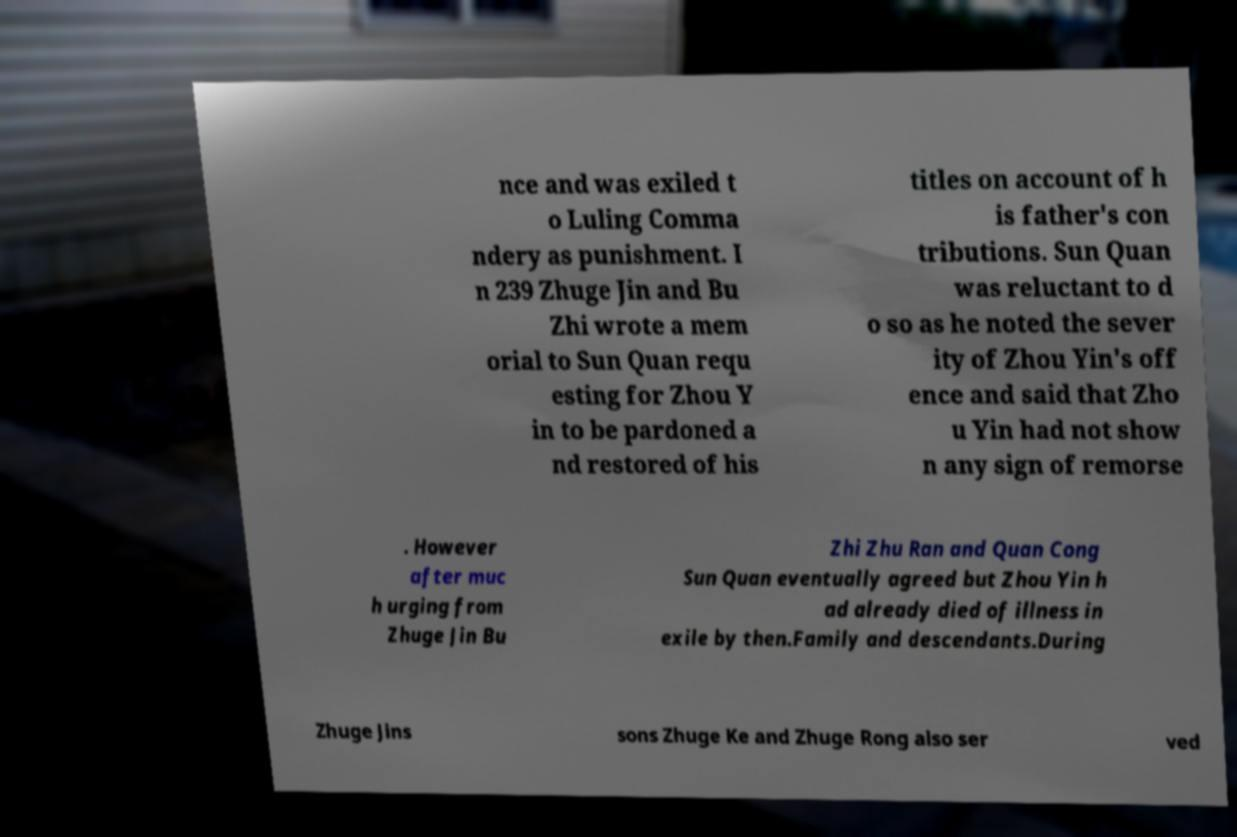Please read and relay the text visible in this image. What does it say? nce and was exiled t o Luling Comma ndery as punishment. I n 239 Zhuge Jin and Bu Zhi wrote a mem orial to Sun Quan requ esting for Zhou Y in to be pardoned a nd restored of his titles on account of h is father's con tributions. Sun Quan was reluctant to d o so as he noted the sever ity of Zhou Yin's off ence and said that Zho u Yin had not show n any sign of remorse . However after muc h urging from Zhuge Jin Bu Zhi Zhu Ran and Quan Cong Sun Quan eventually agreed but Zhou Yin h ad already died of illness in exile by then.Family and descendants.During Zhuge Jins sons Zhuge Ke and Zhuge Rong also ser ved 